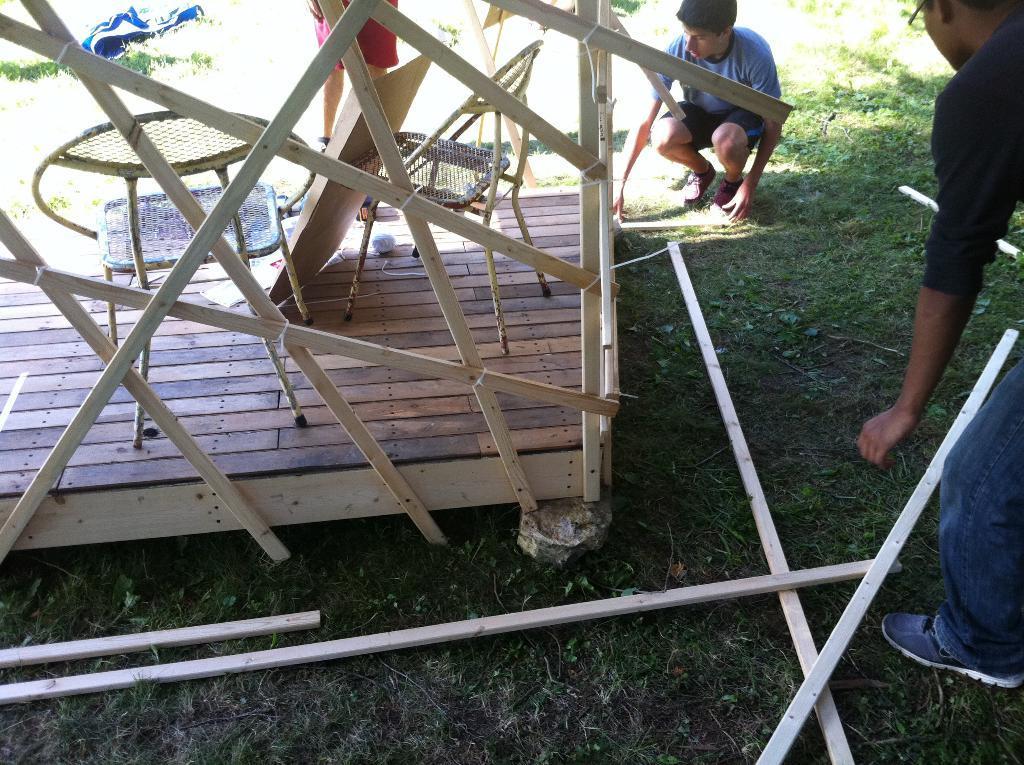In one or two sentences, can you explain what this image depicts? In this image we can see chairs and a cardboard on the wooden platform, there are three persons and few wooden sticks on the ground. 